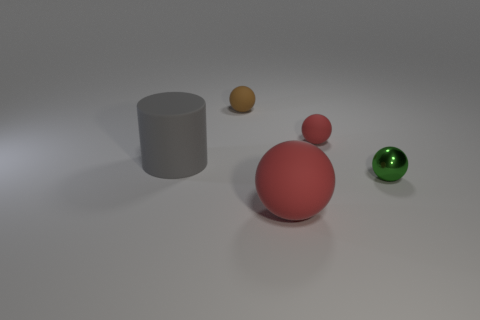Are there fewer large gray rubber objects to the right of the small red object than tiny gray metallic cubes?
Keep it short and to the point. No. Are there any green metallic objects on the left side of the brown matte sphere?
Give a very brief answer. No. Is there a tiny brown matte object that has the same shape as the gray object?
Provide a short and direct response. No. There is a metal thing that is the same size as the brown matte thing; what shape is it?
Offer a very short reply. Sphere. What number of objects are either balls that are on the right side of the brown matte object or tiny red cylinders?
Your answer should be very brief. 3. Do the large matte cylinder and the shiny thing have the same color?
Your answer should be compact. No. There is a red rubber thing behind the large rubber cylinder; what is its size?
Offer a terse response. Small. Are there any other gray things that have the same size as the shiny object?
Keep it short and to the point. No. Is the size of the object that is on the left side of the brown rubber object the same as the tiny red sphere?
Your answer should be compact. No. How big is the gray cylinder?
Your answer should be compact. Large. 